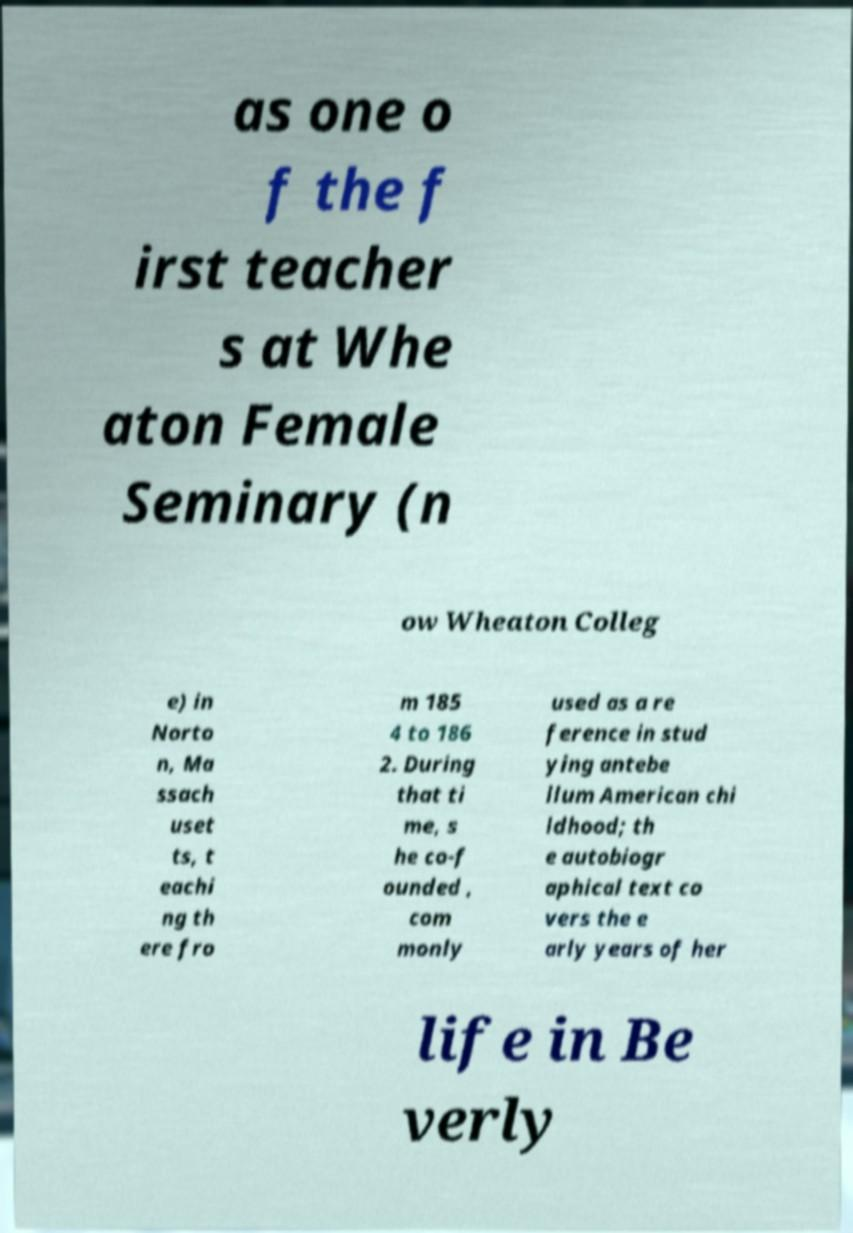Could you assist in decoding the text presented in this image and type it out clearly? as one o f the f irst teacher s at Whe aton Female Seminary (n ow Wheaton Colleg e) in Norto n, Ma ssach uset ts, t eachi ng th ere fro m 185 4 to 186 2. During that ti me, s he co-f ounded , com monly used as a re ference in stud ying antebe llum American chi ldhood; th e autobiogr aphical text co vers the e arly years of her life in Be verly 